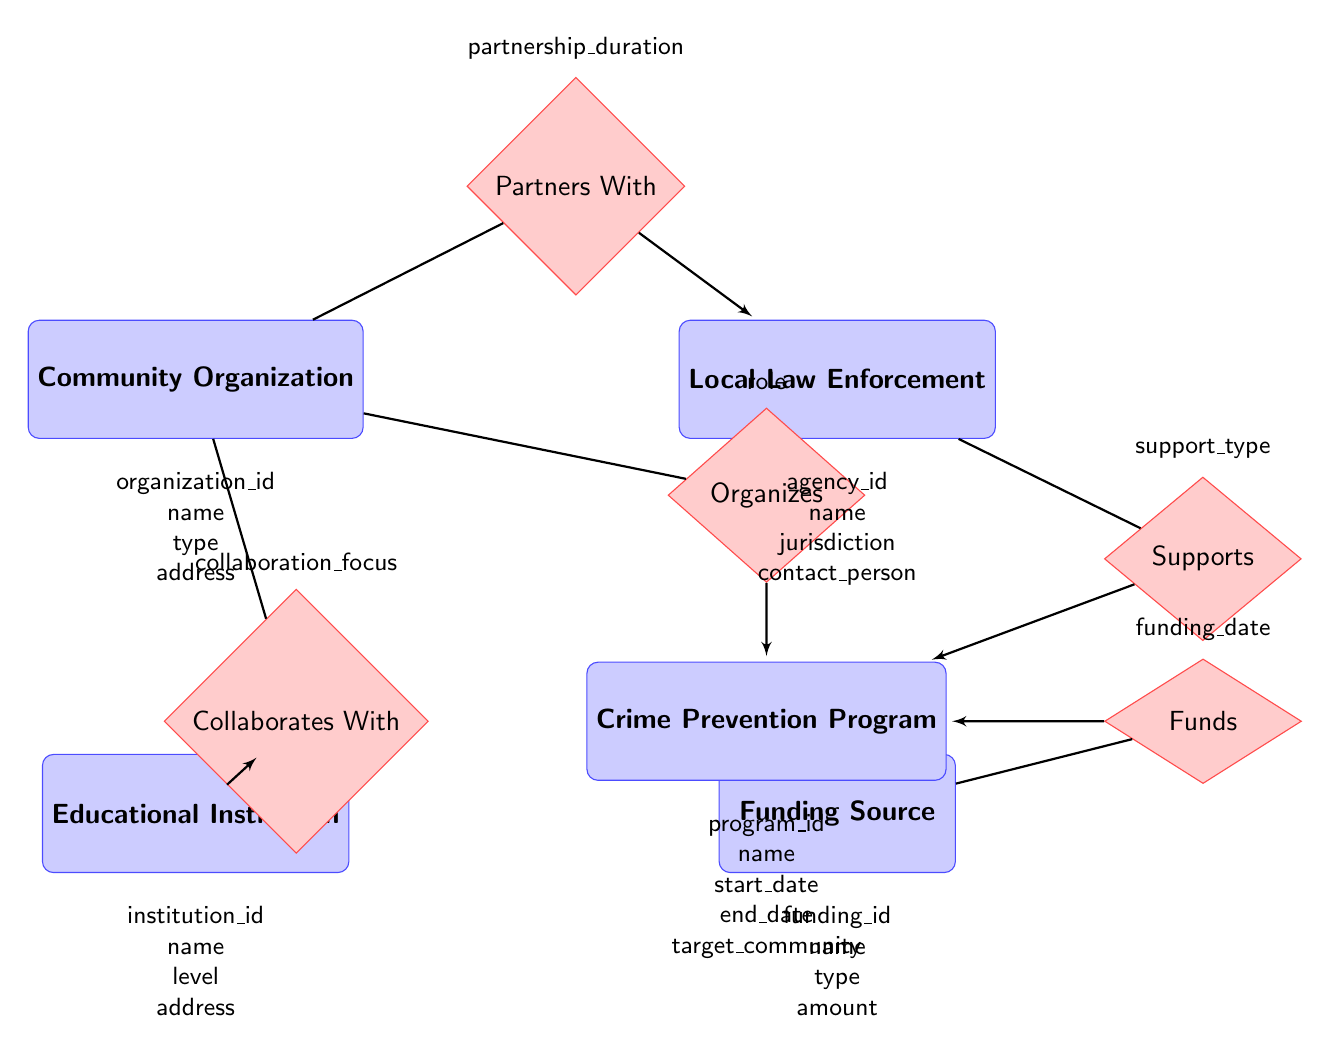What entities are involved in crime prevention programs? The diagram lists five entities: Community Organization, Local Law Enforcement, Educational Institution, Funding Source, and Crime Prevention Program.
Answer: Community Organization, Local Law Enforcement, Educational Institution, Funding Source, Crime Prevention Program What is one of the attributes of Community Organization? The attributes for Community Organization include organization_id, name, type, and address. One example is "name".
Answer: name How many relationships are shown in the diagram? The diagram features five relationships: Partners With, Collaborates With, Funds, Organizes, and Supports. Therefore, the total count is five.
Answer: 5 Who collaborates with Community Organization? According to the diagram, Educational Institution collaborates with Community Organization through the relationship "Collaborates With".
Answer: Educational Institution What is the focus of the collaboration between Educational Institution and Community Organization? The diagram includes an attribute labeled "collaboration_focus" in the relationship "Collaborates With", which identifies the nature of this collaboration but does not specify the actual focus in this context.
Answer: collaboration_focus Which entity has the attribute "amount"? The attribute "amount" belongs to the entity Funding Source, which indicates the financial aspect of this entity in relation to funding programs.
Answer: Funding Source What does Local Law Enforcement support? The Local Law Enforcement supports the Crime Prevention Program through the relationship "Supports", which details the type of assistance provided.
Answer: Crime Prevention Program What is indicated by the relationship "Funds"? The relationship "Funds" indicates that the Funding Source provides financial resources to Crime Prevention Program on a specific date, denoted by the attribute "funding_date".
Answer: Funding Source What defines the nature of the partnership between Community Organization and Local Law Enforcement? The partnership between Community Organization and Local Law Enforcement is characterized by the attribute "partnership_duration", detailing how long they have been in partnership.
Answer: partnership_duration 